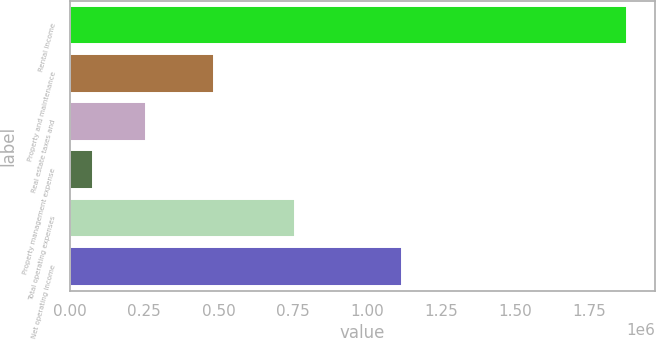<chart> <loc_0><loc_0><loc_500><loc_500><bar_chart><fcel>Rental income<fcel>Property and maintenance<fcel>Real estate taxes and<fcel>Property management expense<fcel>Total operating expenses<fcel>Net operating income<nl><fcel>1.87627e+06<fcel>485754<fcel>256984<fcel>77063<fcel>757488<fcel>1.11878e+06<nl></chart> 